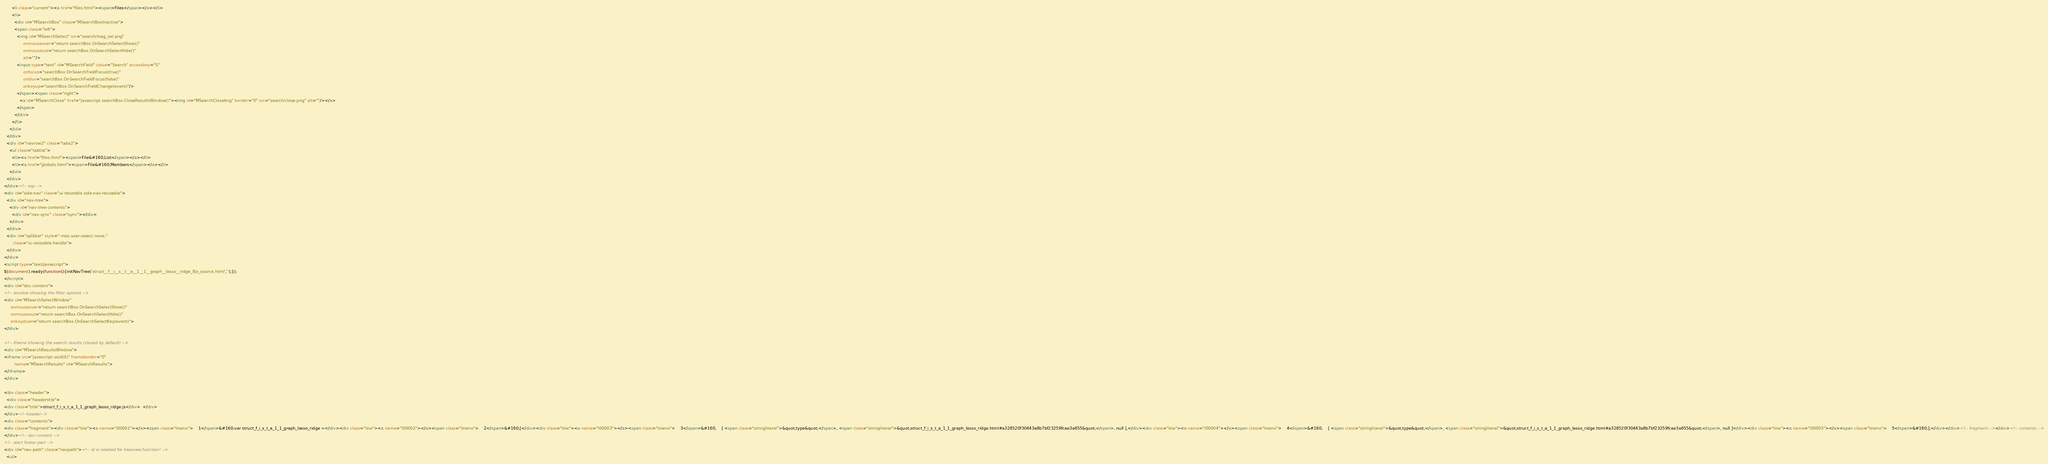<code> <loc_0><loc_0><loc_500><loc_500><_HTML_>      <li class="current"><a href="files.html"><span>Files</span></a></li>
      <li>
        <div id="MSearchBox" class="MSearchBoxInactive">
        <span class="left">
          <img id="MSearchSelect" src="search/mag_sel.png"
               onmouseover="return searchBox.OnSearchSelectShow()"
               onmouseout="return searchBox.OnSearchSelectHide()"
               alt=""/>
          <input type="text" id="MSearchField" value="Search" accesskey="S"
               onfocus="searchBox.OnSearchFieldFocus(true)" 
               onblur="searchBox.OnSearchFieldFocus(false)" 
               onkeyup="searchBox.OnSearchFieldChange(event)"/>
          </span><span class="right">
            <a id="MSearchClose" href="javascript:searchBox.CloseResultsWindow()"><img id="MSearchCloseImg" border="0" src="search/close.png" alt=""/></a>
          </span>
        </div>
      </li>
    </ul>
  </div>
  <div id="navrow2" class="tabs2">
    <ul class="tablist">
      <li><a href="files.html"><span>File&#160;List</span></a></li>
      <li><a href="globals.html"><span>File&#160;Members</span></a></li>
    </ul>
  </div>
</div><!-- top -->
<div id="side-nav" class="ui-resizable side-nav-resizable">
  <div id="nav-tree">
    <div id="nav-tree-contents">
      <div id="nav-sync" class="sync"></div>
    </div>
  </div>
  <div id="splitbar" style="-moz-user-select:none;" 
       class="ui-resizable-handle">
  </div>
</div>
<script type="text/javascript">
$(document).ready(function(){initNavTree('struct__f__i__s__t__a__1__1__graph__lasso__ridge_8js_source.html','');});
</script>
<div id="doc-content">
<!-- window showing the filter options -->
<div id="MSearchSelectWindow"
     onmouseover="return searchBox.OnSearchSelectShow()"
     onmouseout="return searchBox.OnSearchSelectHide()"
     onkeydown="return searchBox.OnSearchSelectKey(event)">
</div>

<!-- iframe showing the search results (closed by default) -->
<div id="MSearchResultsWindow">
<iframe src="javascript:void(0)" frameborder="0" 
        name="MSearchResults" id="MSearchResults">
</iframe>
</div>

<div class="header">
  <div class="headertitle">
<div class="title">struct_f_i_s_t_a_1_1_graph_lasso_ridge.js</div>  </div>
</div><!--header-->
<div class="contents">
<div class="fragment"><div class="line"><a name="l00001"></a><span class="lineno">    1</span>&#160;var struct_f_i_s_t_a_1_1_graph_lasso_ridge =</div><div class="line"><a name="l00002"></a><span class="lineno">    2</span>&#160;[</div><div class="line"><a name="l00003"></a><span class="lineno">    3</span>&#160;    [ <span class="stringliteral">&quot;type&quot;</span>, <span class="stringliteral">&quot;struct_f_i_s_t_a_1_1_graph_lasso_ridge.html#a328520f30443a8b7bf23259fcae3a655&quot;</span>, null ],</div><div class="line"><a name="l00004"></a><span class="lineno">    4</span>&#160;    [ <span class="stringliteral">&quot;type&quot;</span>, <span class="stringliteral">&quot;struct_f_i_s_t_a_1_1_graph_lasso_ridge.html#a328520f30443a8b7bf23259fcae3a655&quot;</span>, null ]</div><div class="line"><a name="l00005"></a><span class="lineno">    5</span>&#160;];</div></div><!-- fragment --></div><!-- contents -->
</div><!-- doc-content -->
<!-- start footer part -->
<div id="nav-path" class="navpath"><!-- id is needed for treeview function! -->
  <ul></code> 